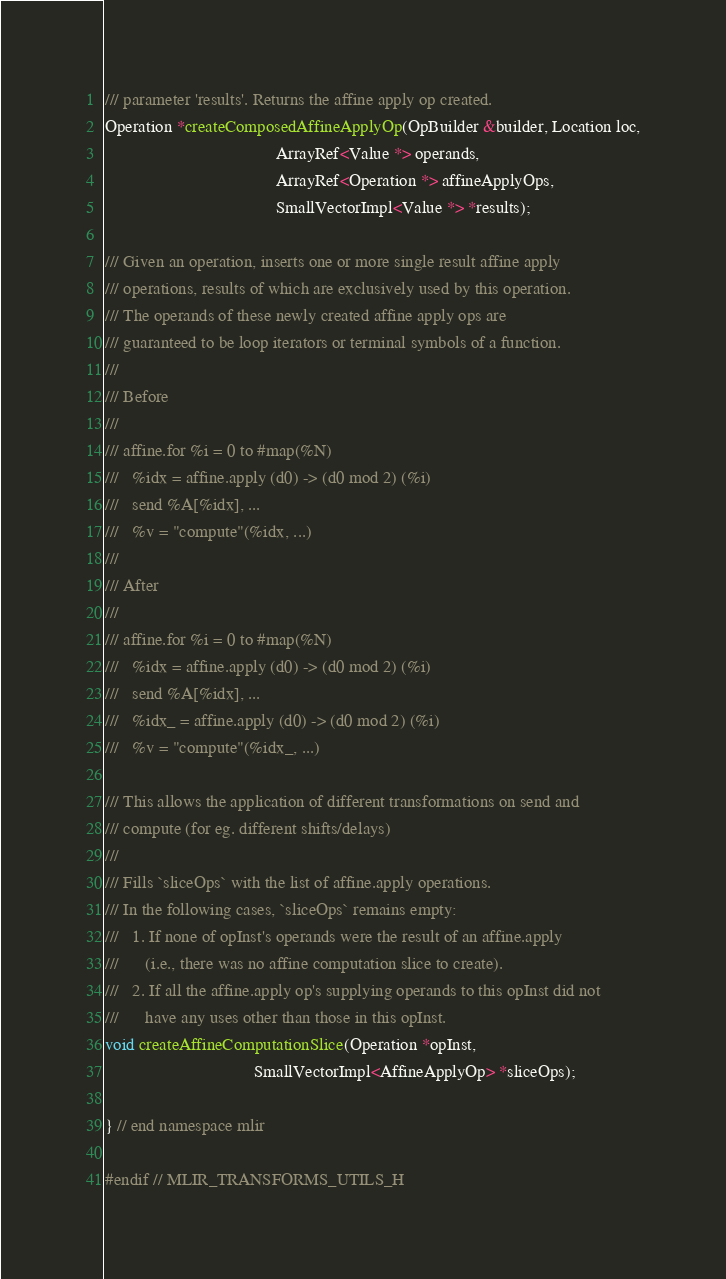Convert code to text. <code><loc_0><loc_0><loc_500><loc_500><_C_>/// parameter 'results'. Returns the affine apply op created.
Operation *createComposedAffineApplyOp(OpBuilder &builder, Location loc,
                                       ArrayRef<Value *> operands,
                                       ArrayRef<Operation *> affineApplyOps,
                                       SmallVectorImpl<Value *> *results);

/// Given an operation, inserts one or more single result affine apply
/// operations, results of which are exclusively used by this operation.
/// The operands of these newly created affine apply ops are
/// guaranteed to be loop iterators or terminal symbols of a function.
///
/// Before
///
/// affine.for %i = 0 to #map(%N)
///   %idx = affine.apply (d0) -> (d0 mod 2) (%i)
///   send %A[%idx], ...
///   %v = "compute"(%idx, ...)
///
/// After
///
/// affine.for %i = 0 to #map(%N)
///   %idx = affine.apply (d0) -> (d0 mod 2) (%i)
///   send %A[%idx], ...
///   %idx_ = affine.apply (d0) -> (d0 mod 2) (%i)
///   %v = "compute"(%idx_, ...)

/// This allows the application of different transformations on send and
/// compute (for eg. different shifts/delays)
///
/// Fills `sliceOps` with the list of affine.apply operations.
/// In the following cases, `sliceOps` remains empty:
///   1. If none of opInst's operands were the result of an affine.apply
///      (i.e., there was no affine computation slice to create).
///   2. If all the affine.apply op's supplying operands to this opInst did not
///      have any uses other than those in this opInst.
void createAffineComputationSlice(Operation *opInst,
                                  SmallVectorImpl<AffineApplyOp> *sliceOps);

} // end namespace mlir

#endif // MLIR_TRANSFORMS_UTILS_H
</code> 